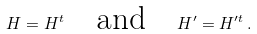Convert formula to latex. <formula><loc_0><loc_0><loc_500><loc_500>H = H ^ { t } \quad \text {and} \quad H ^ { \prime } = H ^ { \prime t } \, .</formula> 